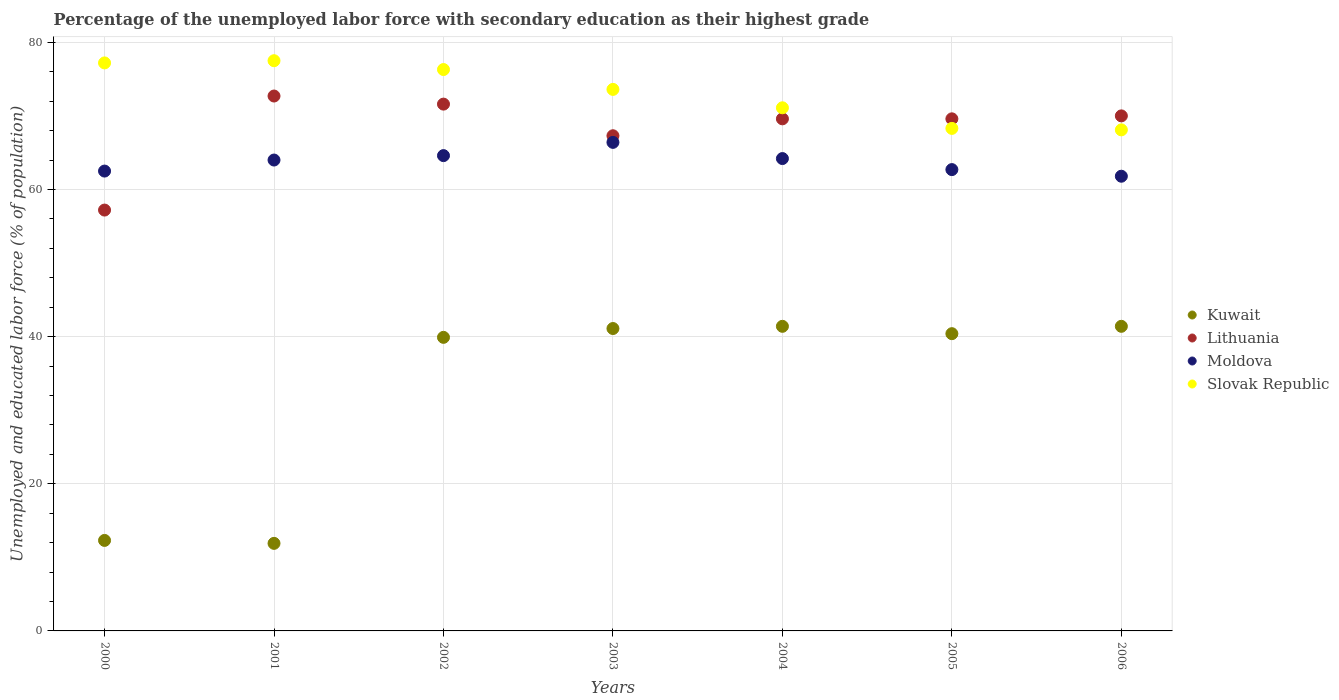Is the number of dotlines equal to the number of legend labels?
Your answer should be compact. Yes. Across all years, what is the maximum percentage of the unemployed labor force with secondary education in Slovak Republic?
Make the answer very short. 77.5. Across all years, what is the minimum percentage of the unemployed labor force with secondary education in Kuwait?
Your answer should be very brief. 11.9. In which year was the percentage of the unemployed labor force with secondary education in Moldova minimum?
Your answer should be compact. 2006. What is the total percentage of the unemployed labor force with secondary education in Lithuania in the graph?
Provide a succinct answer. 478. What is the difference between the percentage of the unemployed labor force with secondary education in Lithuania in 2002 and that in 2006?
Keep it short and to the point. 1.6. What is the difference between the percentage of the unemployed labor force with secondary education in Kuwait in 2003 and the percentage of the unemployed labor force with secondary education in Slovak Republic in 2001?
Offer a very short reply. -36.4. What is the average percentage of the unemployed labor force with secondary education in Lithuania per year?
Your answer should be very brief. 68.29. In the year 2002, what is the difference between the percentage of the unemployed labor force with secondary education in Slovak Republic and percentage of the unemployed labor force with secondary education in Kuwait?
Give a very brief answer. 36.4. What is the ratio of the percentage of the unemployed labor force with secondary education in Lithuania in 2001 to that in 2005?
Make the answer very short. 1.04. Is the difference between the percentage of the unemployed labor force with secondary education in Slovak Republic in 2001 and 2006 greater than the difference between the percentage of the unemployed labor force with secondary education in Kuwait in 2001 and 2006?
Your answer should be compact. Yes. What is the difference between the highest and the second highest percentage of the unemployed labor force with secondary education in Moldova?
Your answer should be compact. 1.8. What is the difference between the highest and the lowest percentage of the unemployed labor force with secondary education in Moldova?
Provide a succinct answer. 4.6. Is the sum of the percentage of the unemployed labor force with secondary education in Lithuania in 2003 and 2004 greater than the maximum percentage of the unemployed labor force with secondary education in Slovak Republic across all years?
Give a very brief answer. Yes. Does the percentage of the unemployed labor force with secondary education in Kuwait monotonically increase over the years?
Offer a very short reply. No. Is the percentage of the unemployed labor force with secondary education in Kuwait strictly less than the percentage of the unemployed labor force with secondary education in Lithuania over the years?
Ensure brevity in your answer.  Yes. How many years are there in the graph?
Provide a short and direct response. 7. Are the values on the major ticks of Y-axis written in scientific E-notation?
Your response must be concise. No. Does the graph contain any zero values?
Your answer should be very brief. No. Does the graph contain grids?
Provide a succinct answer. Yes. How many legend labels are there?
Ensure brevity in your answer.  4. What is the title of the graph?
Offer a terse response. Percentage of the unemployed labor force with secondary education as their highest grade. Does "Kiribati" appear as one of the legend labels in the graph?
Offer a terse response. No. What is the label or title of the Y-axis?
Provide a short and direct response. Unemployed and educated labor force (% of population). What is the Unemployed and educated labor force (% of population) of Kuwait in 2000?
Give a very brief answer. 12.3. What is the Unemployed and educated labor force (% of population) of Lithuania in 2000?
Give a very brief answer. 57.2. What is the Unemployed and educated labor force (% of population) in Moldova in 2000?
Your answer should be very brief. 62.5. What is the Unemployed and educated labor force (% of population) of Slovak Republic in 2000?
Provide a succinct answer. 77.2. What is the Unemployed and educated labor force (% of population) in Kuwait in 2001?
Offer a very short reply. 11.9. What is the Unemployed and educated labor force (% of population) in Lithuania in 2001?
Offer a very short reply. 72.7. What is the Unemployed and educated labor force (% of population) of Moldova in 2001?
Ensure brevity in your answer.  64. What is the Unemployed and educated labor force (% of population) in Slovak Republic in 2001?
Provide a short and direct response. 77.5. What is the Unemployed and educated labor force (% of population) in Kuwait in 2002?
Give a very brief answer. 39.9. What is the Unemployed and educated labor force (% of population) of Lithuania in 2002?
Make the answer very short. 71.6. What is the Unemployed and educated labor force (% of population) in Moldova in 2002?
Your response must be concise. 64.6. What is the Unemployed and educated labor force (% of population) of Slovak Republic in 2002?
Ensure brevity in your answer.  76.3. What is the Unemployed and educated labor force (% of population) of Kuwait in 2003?
Provide a succinct answer. 41.1. What is the Unemployed and educated labor force (% of population) in Lithuania in 2003?
Ensure brevity in your answer.  67.3. What is the Unemployed and educated labor force (% of population) of Moldova in 2003?
Provide a succinct answer. 66.4. What is the Unemployed and educated labor force (% of population) of Slovak Republic in 2003?
Offer a terse response. 73.6. What is the Unemployed and educated labor force (% of population) of Kuwait in 2004?
Provide a succinct answer. 41.4. What is the Unemployed and educated labor force (% of population) of Lithuania in 2004?
Offer a terse response. 69.6. What is the Unemployed and educated labor force (% of population) in Moldova in 2004?
Give a very brief answer. 64.2. What is the Unemployed and educated labor force (% of population) in Slovak Republic in 2004?
Give a very brief answer. 71.1. What is the Unemployed and educated labor force (% of population) in Kuwait in 2005?
Keep it short and to the point. 40.4. What is the Unemployed and educated labor force (% of population) of Lithuania in 2005?
Your response must be concise. 69.6. What is the Unemployed and educated labor force (% of population) in Moldova in 2005?
Provide a succinct answer. 62.7. What is the Unemployed and educated labor force (% of population) in Slovak Republic in 2005?
Your answer should be compact. 68.3. What is the Unemployed and educated labor force (% of population) of Kuwait in 2006?
Offer a terse response. 41.4. What is the Unemployed and educated labor force (% of population) in Lithuania in 2006?
Your answer should be very brief. 70. What is the Unemployed and educated labor force (% of population) in Moldova in 2006?
Offer a very short reply. 61.8. What is the Unemployed and educated labor force (% of population) in Slovak Republic in 2006?
Provide a short and direct response. 68.1. Across all years, what is the maximum Unemployed and educated labor force (% of population) of Kuwait?
Give a very brief answer. 41.4. Across all years, what is the maximum Unemployed and educated labor force (% of population) of Lithuania?
Offer a terse response. 72.7. Across all years, what is the maximum Unemployed and educated labor force (% of population) in Moldova?
Provide a succinct answer. 66.4. Across all years, what is the maximum Unemployed and educated labor force (% of population) in Slovak Republic?
Your response must be concise. 77.5. Across all years, what is the minimum Unemployed and educated labor force (% of population) of Kuwait?
Keep it short and to the point. 11.9. Across all years, what is the minimum Unemployed and educated labor force (% of population) in Lithuania?
Provide a short and direct response. 57.2. Across all years, what is the minimum Unemployed and educated labor force (% of population) in Moldova?
Keep it short and to the point. 61.8. Across all years, what is the minimum Unemployed and educated labor force (% of population) in Slovak Republic?
Your answer should be compact. 68.1. What is the total Unemployed and educated labor force (% of population) of Kuwait in the graph?
Provide a short and direct response. 228.4. What is the total Unemployed and educated labor force (% of population) in Lithuania in the graph?
Make the answer very short. 478. What is the total Unemployed and educated labor force (% of population) in Moldova in the graph?
Keep it short and to the point. 446.2. What is the total Unemployed and educated labor force (% of population) in Slovak Republic in the graph?
Provide a succinct answer. 512.1. What is the difference between the Unemployed and educated labor force (% of population) in Kuwait in 2000 and that in 2001?
Provide a succinct answer. 0.4. What is the difference between the Unemployed and educated labor force (% of population) in Lithuania in 2000 and that in 2001?
Offer a terse response. -15.5. What is the difference between the Unemployed and educated labor force (% of population) in Kuwait in 2000 and that in 2002?
Offer a terse response. -27.6. What is the difference between the Unemployed and educated labor force (% of population) of Lithuania in 2000 and that in 2002?
Keep it short and to the point. -14.4. What is the difference between the Unemployed and educated labor force (% of population) in Kuwait in 2000 and that in 2003?
Ensure brevity in your answer.  -28.8. What is the difference between the Unemployed and educated labor force (% of population) of Lithuania in 2000 and that in 2003?
Provide a short and direct response. -10.1. What is the difference between the Unemployed and educated labor force (% of population) in Moldova in 2000 and that in 2003?
Your answer should be very brief. -3.9. What is the difference between the Unemployed and educated labor force (% of population) in Slovak Republic in 2000 and that in 2003?
Ensure brevity in your answer.  3.6. What is the difference between the Unemployed and educated labor force (% of population) in Kuwait in 2000 and that in 2004?
Your answer should be very brief. -29.1. What is the difference between the Unemployed and educated labor force (% of population) in Moldova in 2000 and that in 2004?
Offer a terse response. -1.7. What is the difference between the Unemployed and educated labor force (% of population) of Slovak Republic in 2000 and that in 2004?
Make the answer very short. 6.1. What is the difference between the Unemployed and educated labor force (% of population) of Kuwait in 2000 and that in 2005?
Your answer should be compact. -28.1. What is the difference between the Unemployed and educated labor force (% of population) of Lithuania in 2000 and that in 2005?
Offer a terse response. -12.4. What is the difference between the Unemployed and educated labor force (% of population) in Moldova in 2000 and that in 2005?
Give a very brief answer. -0.2. What is the difference between the Unemployed and educated labor force (% of population) in Kuwait in 2000 and that in 2006?
Make the answer very short. -29.1. What is the difference between the Unemployed and educated labor force (% of population) in Lithuania in 2000 and that in 2006?
Provide a succinct answer. -12.8. What is the difference between the Unemployed and educated labor force (% of population) of Slovak Republic in 2000 and that in 2006?
Ensure brevity in your answer.  9.1. What is the difference between the Unemployed and educated labor force (% of population) in Moldova in 2001 and that in 2002?
Keep it short and to the point. -0.6. What is the difference between the Unemployed and educated labor force (% of population) of Kuwait in 2001 and that in 2003?
Your answer should be very brief. -29.2. What is the difference between the Unemployed and educated labor force (% of population) in Moldova in 2001 and that in 2003?
Give a very brief answer. -2.4. What is the difference between the Unemployed and educated labor force (% of population) in Slovak Republic in 2001 and that in 2003?
Give a very brief answer. 3.9. What is the difference between the Unemployed and educated labor force (% of population) in Kuwait in 2001 and that in 2004?
Provide a short and direct response. -29.5. What is the difference between the Unemployed and educated labor force (% of population) of Moldova in 2001 and that in 2004?
Provide a succinct answer. -0.2. What is the difference between the Unemployed and educated labor force (% of population) of Kuwait in 2001 and that in 2005?
Your answer should be very brief. -28.5. What is the difference between the Unemployed and educated labor force (% of population) in Lithuania in 2001 and that in 2005?
Offer a terse response. 3.1. What is the difference between the Unemployed and educated labor force (% of population) of Moldova in 2001 and that in 2005?
Your answer should be compact. 1.3. What is the difference between the Unemployed and educated labor force (% of population) in Slovak Republic in 2001 and that in 2005?
Offer a very short reply. 9.2. What is the difference between the Unemployed and educated labor force (% of population) in Kuwait in 2001 and that in 2006?
Offer a terse response. -29.5. What is the difference between the Unemployed and educated labor force (% of population) in Lithuania in 2001 and that in 2006?
Keep it short and to the point. 2.7. What is the difference between the Unemployed and educated labor force (% of population) of Moldova in 2001 and that in 2006?
Your response must be concise. 2.2. What is the difference between the Unemployed and educated labor force (% of population) in Moldova in 2002 and that in 2003?
Your answer should be compact. -1.8. What is the difference between the Unemployed and educated labor force (% of population) of Kuwait in 2002 and that in 2004?
Provide a succinct answer. -1.5. What is the difference between the Unemployed and educated labor force (% of population) of Lithuania in 2002 and that in 2004?
Your answer should be compact. 2. What is the difference between the Unemployed and educated labor force (% of population) of Moldova in 2002 and that in 2004?
Keep it short and to the point. 0.4. What is the difference between the Unemployed and educated labor force (% of population) of Kuwait in 2002 and that in 2005?
Keep it short and to the point. -0.5. What is the difference between the Unemployed and educated labor force (% of population) in Lithuania in 2002 and that in 2005?
Offer a terse response. 2. What is the difference between the Unemployed and educated labor force (% of population) of Moldova in 2002 and that in 2005?
Your answer should be compact. 1.9. What is the difference between the Unemployed and educated labor force (% of population) of Slovak Republic in 2002 and that in 2005?
Make the answer very short. 8. What is the difference between the Unemployed and educated labor force (% of population) in Kuwait in 2002 and that in 2006?
Offer a terse response. -1.5. What is the difference between the Unemployed and educated labor force (% of population) in Slovak Republic in 2002 and that in 2006?
Offer a terse response. 8.2. What is the difference between the Unemployed and educated labor force (% of population) in Lithuania in 2003 and that in 2004?
Your response must be concise. -2.3. What is the difference between the Unemployed and educated labor force (% of population) in Moldova in 2003 and that in 2004?
Offer a very short reply. 2.2. What is the difference between the Unemployed and educated labor force (% of population) in Lithuania in 2003 and that in 2005?
Provide a short and direct response. -2.3. What is the difference between the Unemployed and educated labor force (% of population) in Moldova in 2003 and that in 2005?
Ensure brevity in your answer.  3.7. What is the difference between the Unemployed and educated labor force (% of population) of Lithuania in 2003 and that in 2006?
Your answer should be very brief. -2.7. What is the difference between the Unemployed and educated labor force (% of population) in Moldova in 2003 and that in 2006?
Your answer should be very brief. 4.6. What is the difference between the Unemployed and educated labor force (% of population) in Moldova in 2004 and that in 2005?
Offer a terse response. 1.5. What is the difference between the Unemployed and educated labor force (% of population) in Kuwait in 2004 and that in 2006?
Make the answer very short. 0. What is the difference between the Unemployed and educated labor force (% of population) of Lithuania in 2004 and that in 2006?
Offer a terse response. -0.4. What is the difference between the Unemployed and educated labor force (% of population) in Moldova in 2004 and that in 2006?
Provide a short and direct response. 2.4. What is the difference between the Unemployed and educated labor force (% of population) of Slovak Republic in 2004 and that in 2006?
Offer a terse response. 3. What is the difference between the Unemployed and educated labor force (% of population) of Kuwait in 2005 and that in 2006?
Offer a terse response. -1. What is the difference between the Unemployed and educated labor force (% of population) in Moldova in 2005 and that in 2006?
Your answer should be very brief. 0.9. What is the difference between the Unemployed and educated labor force (% of population) of Slovak Republic in 2005 and that in 2006?
Provide a succinct answer. 0.2. What is the difference between the Unemployed and educated labor force (% of population) in Kuwait in 2000 and the Unemployed and educated labor force (% of population) in Lithuania in 2001?
Keep it short and to the point. -60.4. What is the difference between the Unemployed and educated labor force (% of population) in Kuwait in 2000 and the Unemployed and educated labor force (% of population) in Moldova in 2001?
Provide a short and direct response. -51.7. What is the difference between the Unemployed and educated labor force (% of population) in Kuwait in 2000 and the Unemployed and educated labor force (% of population) in Slovak Republic in 2001?
Offer a terse response. -65.2. What is the difference between the Unemployed and educated labor force (% of population) of Lithuania in 2000 and the Unemployed and educated labor force (% of population) of Slovak Republic in 2001?
Provide a succinct answer. -20.3. What is the difference between the Unemployed and educated labor force (% of population) of Moldova in 2000 and the Unemployed and educated labor force (% of population) of Slovak Republic in 2001?
Your answer should be very brief. -15. What is the difference between the Unemployed and educated labor force (% of population) of Kuwait in 2000 and the Unemployed and educated labor force (% of population) of Lithuania in 2002?
Offer a terse response. -59.3. What is the difference between the Unemployed and educated labor force (% of population) in Kuwait in 2000 and the Unemployed and educated labor force (% of population) in Moldova in 2002?
Keep it short and to the point. -52.3. What is the difference between the Unemployed and educated labor force (% of population) of Kuwait in 2000 and the Unemployed and educated labor force (% of population) of Slovak Republic in 2002?
Make the answer very short. -64. What is the difference between the Unemployed and educated labor force (% of population) of Lithuania in 2000 and the Unemployed and educated labor force (% of population) of Slovak Republic in 2002?
Provide a succinct answer. -19.1. What is the difference between the Unemployed and educated labor force (% of population) in Moldova in 2000 and the Unemployed and educated labor force (% of population) in Slovak Republic in 2002?
Provide a succinct answer. -13.8. What is the difference between the Unemployed and educated labor force (% of population) of Kuwait in 2000 and the Unemployed and educated labor force (% of population) of Lithuania in 2003?
Give a very brief answer. -55. What is the difference between the Unemployed and educated labor force (% of population) in Kuwait in 2000 and the Unemployed and educated labor force (% of population) in Moldova in 2003?
Ensure brevity in your answer.  -54.1. What is the difference between the Unemployed and educated labor force (% of population) of Kuwait in 2000 and the Unemployed and educated labor force (% of population) of Slovak Republic in 2003?
Ensure brevity in your answer.  -61.3. What is the difference between the Unemployed and educated labor force (% of population) in Lithuania in 2000 and the Unemployed and educated labor force (% of population) in Slovak Republic in 2003?
Your answer should be compact. -16.4. What is the difference between the Unemployed and educated labor force (% of population) of Moldova in 2000 and the Unemployed and educated labor force (% of population) of Slovak Republic in 2003?
Keep it short and to the point. -11.1. What is the difference between the Unemployed and educated labor force (% of population) in Kuwait in 2000 and the Unemployed and educated labor force (% of population) in Lithuania in 2004?
Offer a very short reply. -57.3. What is the difference between the Unemployed and educated labor force (% of population) in Kuwait in 2000 and the Unemployed and educated labor force (% of population) in Moldova in 2004?
Make the answer very short. -51.9. What is the difference between the Unemployed and educated labor force (% of population) in Kuwait in 2000 and the Unemployed and educated labor force (% of population) in Slovak Republic in 2004?
Your response must be concise. -58.8. What is the difference between the Unemployed and educated labor force (% of population) of Kuwait in 2000 and the Unemployed and educated labor force (% of population) of Lithuania in 2005?
Provide a succinct answer. -57.3. What is the difference between the Unemployed and educated labor force (% of population) of Kuwait in 2000 and the Unemployed and educated labor force (% of population) of Moldova in 2005?
Offer a terse response. -50.4. What is the difference between the Unemployed and educated labor force (% of population) in Kuwait in 2000 and the Unemployed and educated labor force (% of population) in Slovak Republic in 2005?
Make the answer very short. -56. What is the difference between the Unemployed and educated labor force (% of population) of Lithuania in 2000 and the Unemployed and educated labor force (% of population) of Moldova in 2005?
Offer a very short reply. -5.5. What is the difference between the Unemployed and educated labor force (% of population) in Lithuania in 2000 and the Unemployed and educated labor force (% of population) in Slovak Republic in 2005?
Offer a very short reply. -11.1. What is the difference between the Unemployed and educated labor force (% of population) of Kuwait in 2000 and the Unemployed and educated labor force (% of population) of Lithuania in 2006?
Give a very brief answer. -57.7. What is the difference between the Unemployed and educated labor force (% of population) of Kuwait in 2000 and the Unemployed and educated labor force (% of population) of Moldova in 2006?
Your answer should be compact. -49.5. What is the difference between the Unemployed and educated labor force (% of population) of Kuwait in 2000 and the Unemployed and educated labor force (% of population) of Slovak Republic in 2006?
Provide a succinct answer. -55.8. What is the difference between the Unemployed and educated labor force (% of population) in Lithuania in 2000 and the Unemployed and educated labor force (% of population) in Moldova in 2006?
Your answer should be compact. -4.6. What is the difference between the Unemployed and educated labor force (% of population) in Lithuania in 2000 and the Unemployed and educated labor force (% of population) in Slovak Republic in 2006?
Provide a succinct answer. -10.9. What is the difference between the Unemployed and educated labor force (% of population) in Kuwait in 2001 and the Unemployed and educated labor force (% of population) in Lithuania in 2002?
Your answer should be compact. -59.7. What is the difference between the Unemployed and educated labor force (% of population) of Kuwait in 2001 and the Unemployed and educated labor force (% of population) of Moldova in 2002?
Make the answer very short. -52.7. What is the difference between the Unemployed and educated labor force (% of population) of Kuwait in 2001 and the Unemployed and educated labor force (% of population) of Slovak Republic in 2002?
Your answer should be compact. -64.4. What is the difference between the Unemployed and educated labor force (% of population) of Kuwait in 2001 and the Unemployed and educated labor force (% of population) of Lithuania in 2003?
Provide a short and direct response. -55.4. What is the difference between the Unemployed and educated labor force (% of population) in Kuwait in 2001 and the Unemployed and educated labor force (% of population) in Moldova in 2003?
Your answer should be very brief. -54.5. What is the difference between the Unemployed and educated labor force (% of population) in Kuwait in 2001 and the Unemployed and educated labor force (% of population) in Slovak Republic in 2003?
Provide a short and direct response. -61.7. What is the difference between the Unemployed and educated labor force (% of population) in Kuwait in 2001 and the Unemployed and educated labor force (% of population) in Lithuania in 2004?
Provide a succinct answer. -57.7. What is the difference between the Unemployed and educated labor force (% of population) of Kuwait in 2001 and the Unemployed and educated labor force (% of population) of Moldova in 2004?
Your answer should be very brief. -52.3. What is the difference between the Unemployed and educated labor force (% of population) of Kuwait in 2001 and the Unemployed and educated labor force (% of population) of Slovak Republic in 2004?
Provide a succinct answer. -59.2. What is the difference between the Unemployed and educated labor force (% of population) in Lithuania in 2001 and the Unemployed and educated labor force (% of population) in Slovak Republic in 2004?
Keep it short and to the point. 1.6. What is the difference between the Unemployed and educated labor force (% of population) of Kuwait in 2001 and the Unemployed and educated labor force (% of population) of Lithuania in 2005?
Ensure brevity in your answer.  -57.7. What is the difference between the Unemployed and educated labor force (% of population) of Kuwait in 2001 and the Unemployed and educated labor force (% of population) of Moldova in 2005?
Provide a succinct answer. -50.8. What is the difference between the Unemployed and educated labor force (% of population) of Kuwait in 2001 and the Unemployed and educated labor force (% of population) of Slovak Republic in 2005?
Offer a terse response. -56.4. What is the difference between the Unemployed and educated labor force (% of population) in Lithuania in 2001 and the Unemployed and educated labor force (% of population) in Moldova in 2005?
Keep it short and to the point. 10. What is the difference between the Unemployed and educated labor force (% of population) of Lithuania in 2001 and the Unemployed and educated labor force (% of population) of Slovak Republic in 2005?
Your answer should be compact. 4.4. What is the difference between the Unemployed and educated labor force (% of population) of Moldova in 2001 and the Unemployed and educated labor force (% of population) of Slovak Republic in 2005?
Your answer should be compact. -4.3. What is the difference between the Unemployed and educated labor force (% of population) in Kuwait in 2001 and the Unemployed and educated labor force (% of population) in Lithuania in 2006?
Offer a terse response. -58.1. What is the difference between the Unemployed and educated labor force (% of population) in Kuwait in 2001 and the Unemployed and educated labor force (% of population) in Moldova in 2006?
Provide a short and direct response. -49.9. What is the difference between the Unemployed and educated labor force (% of population) in Kuwait in 2001 and the Unemployed and educated labor force (% of population) in Slovak Republic in 2006?
Keep it short and to the point. -56.2. What is the difference between the Unemployed and educated labor force (% of population) in Lithuania in 2001 and the Unemployed and educated labor force (% of population) in Moldova in 2006?
Ensure brevity in your answer.  10.9. What is the difference between the Unemployed and educated labor force (% of population) in Lithuania in 2001 and the Unemployed and educated labor force (% of population) in Slovak Republic in 2006?
Keep it short and to the point. 4.6. What is the difference between the Unemployed and educated labor force (% of population) of Moldova in 2001 and the Unemployed and educated labor force (% of population) of Slovak Republic in 2006?
Provide a short and direct response. -4.1. What is the difference between the Unemployed and educated labor force (% of population) of Kuwait in 2002 and the Unemployed and educated labor force (% of population) of Lithuania in 2003?
Provide a short and direct response. -27.4. What is the difference between the Unemployed and educated labor force (% of population) of Kuwait in 2002 and the Unemployed and educated labor force (% of population) of Moldova in 2003?
Give a very brief answer. -26.5. What is the difference between the Unemployed and educated labor force (% of population) of Kuwait in 2002 and the Unemployed and educated labor force (% of population) of Slovak Republic in 2003?
Provide a succinct answer. -33.7. What is the difference between the Unemployed and educated labor force (% of population) in Lithuania in 2002 and the Unemployed and educated labor force (% of population) in Slovak Republic in 2003?
Provide a short and direct response. -2. What is the difference between the Unemployed and educated labor force (% of population) in Moldova in 2002 and the Unemployed and educated labor force (% of population) in Slovak Republic in 2003?
Your answer should be compact. -9. What is the difference between the Unemployed and educated labor force (% of population) of Kuwait in 2002 and the Unemployed and educated labor force (% of population) of Lithuania in 2004?
Your answer should be very brief. -29.7. What is the difference between the Unemployed and educated labor force (% of population) of Kuwait in 2002 and the Unemployed and educated labor force (% of population) of Moldova in 2004?
Your answer should be very brief. -24.3. What is the difference between the Unemployed and educated labor force (% of population) of Kuwait in 2002 and the Unemployed and educated labor force (% of population) of Slovak Republic in 2004?
Offer a very short reply. -31.2. What is the difference between the Unemployed and educated labor force (% of population) of Lithuania in 2002 and the Unemployed and educated labor force (% of population) of Slovak Republic in 2004?
Your answer should be very brief. 0.5. What is the difference between the Unemployed and educated labor force (% of population) in Moldova in 2002 and the Unemployed and educated labor force (% of population) in Slovak Republic in 2004?
Offer a terse response. -6.5. What is the difference between the Unemployed and educated labor force (% of population) in Kuwait in 2002 and the Unemployed and educated labor force (% of population) in Lithuania in 2005?
Your answer should be compact. -29.7. What is the difference between the Unemployed and educated labor force (% of population) in Kuwait in 2002 and the Unemployed and educated labor force (% of population) in Moldova in 2005?
Your answer should be compact. -22.8. What is the difference between the Unemployed and educated labor force (% of population) of Kuwait in 2002 and the Unemployed and educated labor force (% of population) of Slovak Republic in 2005?
Offer a very short reply. -28.4. What is the difference between the Unemployed and educated labor force (% of population) of Moldova in 2002 and the Unemployed and educated labor force (% of population) of Slovak Republic in 2005?
Provide a succinct answer. -3.7. What is the difference between the Unemployed and educated labor force (% of population) of Kuwait in 2002 and the Unemployed and educated labor force (% of population) of Lithuania in 2006?
Your answer should be very brief. -30.1. What is the difference between the Unemployed and educated labor force (% of population) in Kuwait in 2002 and the Unemployed and educated labor force (% of population) in Moldova in 2006?
Make the answer very short. -21.9. What is the difference between the Unemployed and educated labor force (% of population) in Kuwait in 2002 and the Unemployed and educated labor force (% of population) in Slovak Republic in 2006?
Keep it short and to the point. -28.2. What is the difference between the Unemployed and educated labor force (% of population) in Lithuania in 2002 and the Unemployed and educated labor force (% of population) in Moldova in 2006?
Give a very brief answer. 9.8. What is the difference between the Unemployed and educated labor force (% of population) in Lithuania in 2002 and the Unemployed and educated labor force (% of population) in Slovak Republic in 2006?
Keep it short and to the point. 3.5. What is the difference between the Unemployed and educated labor force (% of population) of Moldova in 2002 and the Unemployed and educated labor force (% of population) of Slovak Republic in 2006?
Provide a succinct answer. -3.5. What is the difference between the Unemployed and educated labor force (% of population) in Kuwait in 2003 and the Unemployed and educated labor force (% of population) in Lithuania in 2004?
Give a very brief answer. -28.5. What is the difference between the Unemployed and educated labor force (% of population) of Kuwait in 2003 and the Unemployed and educated labor force (% of population) of Moldova in 2004?
Your response must be concise. -23.1. What is the difference between the Unemployed and educated labor force (% of population) in Kuwait in 2003 and the Unemployed and educated labor force (% of population) in Slovak Republic in 2004?
Offer a very short reply. -30. What is the difference between the Unemployed and educated labor force (% of population) of Lithuania in 2003 and the Unemployed and educated labor force (% of population) of Moldova in 2004?
Your answer should be compact. 3.1. What is the difference between the Unemployed and educated labor force (% of population) in Lithuania in 2003 and the Unemployed and educated labor force (% of population) in Slovak Republic in 2004?
Offer a very short reply. -3.8. What is the difference between the Unemployed and educated labor force (% of population) of Moldova in 2003 and the Unemployed and educated labor force (% of population) of Slovak Republic in 2004?
Provide a short and direct response. -4.7. What is the difference between the Unemployed and educated labor force (% of population) of Kuwait in 2003 and the Unemployed and educated labor force (% of population) of Lithuania in 2005?
Offer a very short reply. -28.5. What is the difference between the Unemployed and educated labor force (% of population) in Kuwait in 2003 and the Unemployed and educated labor force (% of population) in Moldova in 2005?
Give a very brief answer. -21.6. What is the difference between the Unemployed and educated labor force (% of population) in Kuwait in 2003 and the Unemployed and educated labor force (% of population) in Slovak Republic in 2005?
Make the answer very short. -27.2. What is the difference between the Unemployed and educated labor force (% of population) of Moldova in 2003 and the Unemployed and educated labor force (% of population) of Slovak Republic in 2005?
Keep it short and to the point. -1.9. What is the difference between the Unemployed and educated labor force (% of population) of Kuwait in 2003 and the Unemployed and educated labor force (% of population) of Lithuania in 2006?
Give a very brief answer. -28.9. What is the difference between the Unemployed and educated labor force (% of population) of Kuwait in 2003 and the Unemployed and educated labor force (% of population) of Moldova in 2006?
Offer a very short reply. -20.7. What is the difference between the Unemployed and educated labor force (% of population) of Lithuania in 2003 and the Unemployed and educated labor force (% of population) of Moldova in 2006?
Make the answer very short. 5.5. What is the difference between the Unemployed and educated labor force (% of population) of Lithuania in 2003 and the Unemployed and educated labor force (% of population) of Slovak Republic in 2006?
Give a very brief answer. -0.8. What is the difference between the Unemployed and educated labor force (% of population) in Moldova in 2003 and the Unemployed and educated labor force (% of population) in Slovak Republic in 2006?
Provide a short and direct response. -1.7. What is the difference between the Unemployed and educated labor force (% of population) of Kuwait in 2004 and the Unemployed and educated labor force (% of population) of Lithuania in 2005?
Give a very brief answer. -28.2. What is the difference between the Unemployed and educated labor force (% of population) in Kuwait in 2004 and the Unemployed and educated labor force (% of population) in Moldova in 2005?
Your response must be concise. -21.3. What is the difference between the Unemployed and educated labor force (% of population) in Kuwait in 2004 and the Unemployed and educated labor force (% of population) in Slovak Republic in 2005?
Ensure brevity in your answer.  -26.9. What is the difference between the Unemployed and educated labor force (% of population) in Lithuania in 2004 and the Unemployed and educated labor force (% of population) in Slovak Republic in 2005?
Provide a short and direct response. 1.3. What is the difference between the Unemployed and educated labor force (% of population) of Moldova in 2004 and the Unemployed and educated labor force (% of population) of Slovak Republic in 2005?
Ensure brevity in your answer.  -4.1. What is the difference between the Unemployed and educated labor force (% of population) in Kuwait in 2004 and the Unemployed and educated labor force (% of population) in Lithuania in 2006?
Offer a terse response. -28.6. What is the difference between the Unemployed and educated labor force (% of population) of Kuwait in 2004 and the Unemployed and educated labor force (% of population) of Moldova in 2006?
Your answer should be compact. -20.4. What is the difference between the Unemployed and educated labor force (% of population) in Kuwait in 2004 and the Unemployed and educated labor force (% of population) in Slovak Republic in 2006?
Your response must be concise. -26.7. What is the difference between the Unemployed and educated labor force (% of population) of Lithuania in 2004 and the Unemployed and educated labor force (% of population) of Moldova in 2006?
Your answer should be very brief. 7.8. What is the difference between the Unemployed and educated labor force (% of population) of Lithuania in 2004 and the Unemployed and educated labor force (% of population) of Slovak Republic in 2006?
Provide a short and direct response. 1.5. What is the difference between the Unemployed and educated labor force (% of population) in Moldova in 2004 and the Unemployed and educated labor force (% of population) in Slovak Republic in 2006?
Keep it short and to the point. -3.9. What is the difference between the Unemployed and educated labor force (% of population) of Kuwait in 2005 and the Unemployed and educated labor force (% of population) of Lithuania in 2006?
Your answer should be compact. -29.6. What is the difference between the Unemployed and educated labor force (% of population) in Kuwait in 2005 and the Unemployed and educated labor force (% of population) in Moldova in 2006?
Keep it short and to the point. -21.4. What is the difference between the Unemployed and educated labor force (% of population) in Kuwait in 2005 and the Unemployed and educated labor force (% of population) in Slovak Republic in 2006?
Your response must be concise. -27.7. What is the difference between the Unemployed and educated labor force (% of population) in Lithuania in 2005 and the Unemployed and educated labor force (% of population) in Slovak Republic in 2006?
Ensure brevity in your answer.  1.5. What is the difference between the Unemployed and educated labor force (% of population) of Moldova in 2005 and the Unemployed and educated labor force (% of population) of Slovak Republic in 2006?
Give a very brief answer. -5.4. What is the average Unemployed and educated labor force (% of population) of Kuwait per year?
Provide a succinct answer. 32.63. What is the average Unemployed and educated labor force (% of population) in Lithuania per year?
Ensure brevity in your answer.  68.29. What is the average Unemployed and educated labor force (% of population) of Moldova per year?
Provide a short and direct response. 63.74. What is the average Unemployed and educated labor force (% of population) of Slovak Republic per year?
Your answer should be very brief. 73.16. In the year 2000, what is the difference between the Unemployed and educated labor force (% of population) in Kuwait and Unemployed and educated labor force (% of population) in Lithuania?
Offer a terse response. -44.9. In the year 2000, what is the difference between the Unemployed and educated labor force (% of population) of Kuwait and Unemployed and educated labor force (% of population) of Moldova?
Offer a terse response. -50.2. In the year 2000, what is the difference between the Unemployed and educated labor force (% of population) in Kuwait and Unemployed and educated labor force (% of population) in Slovak Republic?
Provide a short and direct response. -64.9. In the year 2000, what is the difference between the Unemployed and educated labor force (% of population) of Moldova and Unemployed and educated labor force (% of population) of Slovak Republic?
Provide a succinct answer. -14.7. In the year 2001, what is the difference between the Unemployed and educated labor force (% of population) in Kuwait and Unemployed and educated labor force (% of population) in Lithuania?
Provide a succinct answer. -60.8. In the year 2001, what is the difference between the Unemployed and educated labor force (% of population) of Kuwait and Unemployed and educated labor force (% of population) of Moldova?
Make the answer very short. -52.1. In the year 2001, what is the difference between the Unemployed and educated labor force (% of population) in Kuwait and Unemployed and educated labor force (% of population) in Slovak Republic?
Your answer should be compact. -65.6. In the year 2001, what is the difference between the Unemployed and educated labor force (% of population) of Lithuania and Unemployed and educated labor force (% of population) of Slovak Republic?
Keep it short and to the point. -4.8. In the year 2001, what is the difference between the Unemployed and educated labor force (% of population) of Moldova and Unemployed and educated labor force (% of population) of Slovak Republic?
Give a very brief answer. -13.5. In the year 2002, what is the difference between the Unemployed and educated labor force (% of population) of Kuwait and Unemployed and educated labor force (% of population) of Lithuania?
Your answer should be compact. -31.7. In the year 2002, what is the difference between the Unemployed and educated labor force (% of population) of Kuwait and Unemployed and educated labor force (% of population) of Moldova?
Make the answer very short. -24.7. In the year 2002, what is the difference between the Unemployed and educated labor force (% of population) of Kuwait and Unemployed and educated labor force (% of population) of Slovak Republic?
Provide a succinct answer. -36.4. In the year 2002, what is the difference between the Unemployed and educated labor force (% of population) of Lithuania and Unemployed and educated labor force (% of population) of Moldova?
Provide a succinct answer. 7. In the year 2002, what is the difference between the Unemployed and educated labor force (% of population) of Moldova and Unemployed and educated labor force (% of population) of Slovak Republic?
Offer a very short reply. -11.7. In the year 2003, what is the difference between the Unemployed and educated labor force (% of population) in Kuwait and Unemployed and educated labor force (% of population) in Lithuania?
Your response must be concise. -26.2. In the year 2003, what is the difference between the Unemployed and educated labor force (% of population) in Kuwait and Unemployed and educated labor force (% of population) in Moldova?
Offer a very short reply. -25.3. In the year 2003, what is the difference between the Unemployed and educated labor force (% of population) in Kuwait and Unemployed and educated labor force (% of population) in Slovak Republic?
Give a very brief answer. -32.5. In the year 2003, what is the difference between the Unemployed and educated labor force (% of population) in Moldova and Unemployed and educated labor force (% of population) in Slovak Republic?
Give a very brief answer. -7.2. In the year 2004, what is the difference between the Unemployed and educated labor force (% of population) in Kuwait and Unemployed and educated labor force (% of population) in Lithuania?
Give a very brief answer. -28.2. In the year 2004, what is the difference between the Unemployed and educated labor force (% of population) of Kuwait and Unemployed and educated labor force (% of population) of Moldova?
Provide a succinct answer. -22.8. In the year 2004, what is the difference between the Unemployed and educated labor force (% of population) in Kuwait and Unemployed and educated labor force (% of population) in Slovak Republic?
Ensure brevity in your answer.  -29.7. In the year 2004, what is the difference between the Unemployed and educated labor force (% of population) of Lithuania and Unemployed and educated labor force (% of population) of Moldova?
Your answer should be compact. 5.4. In the year 2004, what is the difference between the Unemployed and educated labor force (% of population) in Lithuania and Unemployed and educated labor force (% of population) in Slovak Republic?
Provide a succinct answer. -1.5. In the year 2004, what is the difference between the Unemployed and educated labor force (% of population) of Moldova and Unemployed and educated labor force (% of population) of Slovak Republic?
Provide a succinct answer. -6.9. In the year 2005, what is the difference between the Unemployed and educated labor force (% of population) of Kuwait and Unemployed and educated labor force (% of population) of Lithuania?
Ensure brevity in your answer.  -29.2. In the year 2005, what is the difference between the Unemployed and educated labor force (% of population) in Kuwait and Unemployed and educated labor force (% of population) in Moldova?
Offer a terse response. -22.3. In the year 2005, what is the difference between the Unemployed and educated labor force (% of population) in Kuwait and Unemployed and educated labor force (% of population) in Slovak Republic?
Provide a short and direct response. -27.9. In the year 2005, what is the difference between the Unemployed and educated labor force (% of population) in Lithuania and Unemployed and educated labor force (% of population) in Moldova?
Offer a very short reply. 6.9. In the year 2005, what is the difference between the Unemployed and educated labor force (% of population) in Lithuania and Unemployed and educated labor force (% of population) in Slovak Republic?
Give a very brief answer. 1.3. In the year 2006, what is the difference between the Unemployed and educated labor force (% of population) in Kuwait and Unemployed and educated labor force (% of population) in Lithuania?
Provide a succinct answer. -28.6. In the year 2006, what is the difference between the Unemployed and educated labor force (% of population) of Kuwait and Unemployed and educated labor force (% of population) of Moldova?
Your answer should be compact. -20.4. In the year 2006, what is the difference between the Unemployed and educated labor force (% of population) of Kuwait and Unemployed and educated labor force (% of population) of Slovak Republic?
Offer a terse response. -26.7. In the year 2006, what is the difference between the Unemployed and educated labor force (% of population) of Lithuania and Unemployed and educated labor force (% of population) of Moldova?
Offer a very short reply. 8.2. What is the ratio of the Unemployed and educated labor force (% of population) of Kuwait in 2000 to that in 2001?
Provide a short and direct response. 1.03. What is the ratio of the Unemployed and educated labor force (% of population) in Lithuania in 2000 to that in 2001?
Your response must be concise. 0.79. What is the ratio of the Unemployed and educated labor force (% of population) in Moldova in 2000 to that in 2001?
Provide a short and direct response. 0.98. What is the ratio of the Unemployed and educated labor force (% of population) in Kuwait in 2000 to that in 2002?
Make the answer very short. 0.31. What is the ratio of the Unemployed and educated labor force (% of population) of Lithuania in 2000 to that in 2002?
Offer a very short reply. 0.8. What is the ratio of the Unemployed and educated labor force (% of population) in Moldova in 2000 to that in 2002?
Make the answer very short. 0.97. What is the ratio of the Unemployed and educated labor force (% of population) of Slovak Republic in 2000 to that in 2002?
Offer a very short reply. 1.01. What is the ratio of the Unemployed and educated labor force (% of population) of Kuwait in 2000 to that in 2003?
Ensure brevity in your answer.  0.3. What is the ratio of the Unemployed and educated labor force (% of population) of Lithuania in 2000 to that in 2003?
Provide a succinct answer. 0.85. What is the ratio of the Unemployed and educated labor force (% of population) in Moldova in 2000 to that in 2003?
Your answer should be very brief. 0.94. What is the ratio of the Unemployed and educated labor force (% of population) of Slovak Republic in 2000 to that in 2003?
Keep it short and to the point. 1.05. What is the ratio of the Unemployed and educated labor force (% of population) of Kuwait in 2000 to that in 2004?
Make the answer very short. 0.3. What is the ratio of the Unemployed and educated labor force (% of population) of Lithuania in 2000 to that in 2004?
Offer a very short reply. 0.82. What is the ratio of the Unemployed and educated labor force (% of population) in Moldova in 2000 to that in 2004?
Ensure brevity in your answer.  0.97. What is the ratio of the Unemployed and educated labor force (% of population) of Slovak Republic in 2000 to that in 2004?
Provide a short and direct response. 1.09. What is the ratio of the Unemployed and educated labor force (% of population) of Kuwait in 2000 to that in 2005?
Your response must be concise. 0.3. What is the ratio of the Unemployed and educated labor force (% of population) of Lithuania in 2000 to that in 2005?
Offer a terse response. 0.82. What is the ratio of the Unemployed and educated labor force (% of population) in Slovak Republic in 2000 to that in 2005?
Make the answer very short. 1.13. What is the ratio of the Unemployed and educated labor force (% of population) in Kuwait in 2000 to that in 2006?
Offer a terse response. 0.3. What is the ratio of the Unemployed and educated labor force (% of population) in Lithuania in 2000 to that in 2006?
Ensure brevity in your answer.  0.82. What is the ratio of the Unemployed and educated labor force (% of population) in Moldova in 2000 to that in 2006?
Offer a terse response. 1.01. What is the ratio of the Unemployed and educated labor force (% of population) in Slovak Republic in 2000 to that in 2006?
Offer a very short reply. 1.13. What is the ratio of the Unemployed and educated labor force (% of population) in Kuwait in 2001 to that in 2002?
Your answer should be compact. 0.3. What is the ratio of the Unemployed and educated labor force (% of population) of Lithuania in 2001 to that in 2002?
Your answer should be very brief. 1.02. What is the ratio of the Unemployed and educated labor force (% of population) in Moldova in 2001 to that in 2002?
Your answer should be very brief. 0.99. What is the ratio of the Unemployed and educated labor force (% of population) of Slovak Republic in 2001 to that in 2002?
Ensure brevity in your answer.  1.02. What is the ratio of the Unemployed and educated labor force (% of population) of Kuwait in 2001 to that in 2003?
Offer a terse response. 0.29. What is the ratio of the Unemployed and educated labor force (% of population) in Lithuania in 2001 to that in 2003?
Ensure brevity in your answer.  1.08. What is the ratio of the Unemployed and educated labor force (% of population) of Moldova in 2001 to that in 2003?
Keep it short and to the point. 0.96. What is the ratio of the Unemployed and educated labor force (% of population) of Slovak Republic in 2001 to that in 2003?
Your answer should be very brief. 1.05. What is the ratio of the Unemployed and educated labor force (% of population) in Kuwait in 2001 to that in 2004?
Offer a very short reply. 0.29. What is the ratio of the Unemployed and educated labor force (% of population) of Lithuania in 2001 to that in 2004?
Your response must be concise. 1.04. What is the ratio of the Unemployed and educated labor force (% of population) of Slovak Republic in 2001 to that in 2004?
Your answer should be very brief. 1.09. What is the ratio of the Unemployed and educated labor force (% of population) in Kuwait in 2001 to that in 2005?
Provide a succinct answer. 0.29. What is the ratio of the Unemployed and educated labor force (% of population) of Lithuania in 2001 to that in 2005?
Your answer should be very brief. 1.04. What is the ratio of the Unemployed and educated labor force (% of population) in Moldova in 2001 to that in 2005?
Your answer should be very brief. 1.02. What is the ratio of the Unemployed and educated labor force (% of population) in Slovak Republic in 2001 to that in 2005?
Your response must be concise. 1.13. What is the ratio of the Unemployed and educated labor force (% of population) of Kuwait in 2001 to that in 2006?
Your answer should be compact. 0.29. What is the ratio of the Unemployed and educated labor force (% of population) of Lithuania in 2001 to that in 2006?
Make the answer very short. 1.04. What is the ratio of the Unemployed and educated labor force (% of population) of Moldova in 2001 to that in 2006?
Your response must be concise. 1.04. What is the ratio of the Unemployed and educated labor force (% of population) in Slovak Republic in 2001 to that in 2006?
Offer a terse response. 1.14. What is the ratio of the Unemployed and educated labor force (% of population) of Kuwait in 2002 to that in 2003?
Ensure brevity in your answer.  0.97. What is the ratio of the Unemployed and educated labor force (% of population) of Lithuania in 2002 to that in 2003?
Keep it short and to the point. 1.06. What is the ratio of the Unemployed and educated labor force (% of population) of Moldova in 2002 to that in 2003?
Your answer should be compact. 0.97. What is the ratio of the Unemployed and educated labor force (% of population) in Slovak Republic in 2002 to that in 2003?
Offer a very short reply. 1.04. What is the ratio of the Unemployed and educated labor force (% of population) of Kuwait in 2002 to that in 2004?
Your answer should be very brief. 0.96. What is the ratio of the Unemployed and educated labor force (% of population) of Lithuania in 2002 to that in 2004?
Your answer should be compact. 1.03. What is the ratio of the Unemployed and educated labor force (% of population) of Moldova in 2002 to that in 2004?
Provide a succinct answer. 1.01. What is the ratio of the Unemployed and educated labor force (% of population) of Slovak Republic in 2002 to that in 2004?
Make the answer very short. 1.07. What is the ratio of the Unemployed and educated labor force (% of population) of Kuwait in 2002 to that in 2005?
Your answer should be compact. 0.99. What is the ratio of the Unemployed and educated labor force (% of population) of Lithuania in 2002 to that in 2005?
Give a very brief answer. 1.03. What is the ratio of the Unemployed and educated labor force (% of population) in Moldova in 2002 to that in 2005?
Provide a succinct answer. 1.03. What is the ratio of the Unemployed and educated labor force (% of population) in Slovak Republic in 2002 to that in 2005?
Give a very brief answer. 1.12. What is the ratio of the Unemployed and educated labor force (% of population) in Kuwait in 2002 to that in 2006?
Give a very brief answer. 0.96. What is the ratio of the Unemployed and educated labor force (% of population) in Lithuania in 2002 to that in 2006?
Give a very brief answer. 1.02. What is the ratio of the Unemployed and educated labor force (% of population) in Moldova in 2002 to that in 2006?
Your answer should be compact. 1.05. What is the ratio of the Unemployed and educated labor force (% of population) in Slovak Republic in 2002 to that in 2006?
Provide a succinct answer. 1.12. What is the ratio of the Unemployed and educated labor force (% of population) of Moldova in 2003 to that in 2004?
Your response must be concise. 1.03. What is the ratio of the Unemployed and educated labor force (% of population) in Slovak Republic in 2003 to that in 2004?
Offer a very short reply. 1.04. What is the ratio of the Unemployed and educated labor force (% of population) of Kuwait in 2003 to that in 2005?
Offer a very short reply. 1.02. What is the ratio of the Unemployed and educated labor force (% of population) in Lithuania in 2003 to that in 2005?
Offer a terse response. 0.97. What is the ratio of the Unemployed and educated labor force (% of population) in Moldova in 2003 to that in 2005?
Provide a short and direct response. 1.06. What is the ratio of the Unemployed and educated labor force (% of population) in Slovak Republic in 2003 to that in 2005?
Give a very brief answer. 1.08. What is the ratio of the Unemployed and educated labor force (% of population) of Lithuania in 2003 to that in 2006?
Offer a very short reply. 0.96. What is the ratio of the Unemployed and educated labor force (% of population) of Moldova in 2003 to that in 2006?
Offer a very short reply. 1.07. What is the ratio of the Unemployed and educated labor force (% of population) in Slovak Republic in 2003 to that in 2006?
Provide a succinct answer. 1.08. What is the ratio of the Unemployed and educated labor force (% of population) of Kuwait in 2004 to that in 2005?
Provide a short and direct response. 1.02. What is the ratio of the Unemployed and educated labor force (% of population) in Lithuania in 2004 to that in 2005?
Provide a succinct answer. 1. What is the ratio of the Unemployed and educated labor force (% of population) in Moldova in 2004 to that in 2005?
Offer a terse response. 1.02. What is the ratio of the Unemployed and educated labor force (% of population) of Slovak Republic in 2004 to that in 2005?
Make the answer very short. 1.04. What is the ratio of the Unemployed and educated labor force (% of population) in Kuwait in 2004 to that in 2006?
Give a very brief answer. 1. What is the ratio of the Unemployed and educated labor force (% of population) in Lithuania in 2004 to that in 2006?
Provide a succinct answer. 0.99. What is the ratio of the Unemployed and educated labor force (% of population) in Moldova in 2004 to that in 2006?
Your answer should be compact. 1.04. What is the ratio of the Unemployed and educated labor force (% of population) in Slovak Republic in 2004 to that in 2006?
Offer a terse response. 1.04. What is the ratio of the Unemployed and educated labor force (% of population) of Kuwait in 2005 to that in 2006?
Ensure brevity in your answer.  0.98. What is the ratio of the Unemployed and educated labor force (% of population) in Lithuania in 2005 to that in 2006?
Offer a very short reply. 0.99. What is the ratio of the Unemployed and educated labor force (% of population) in Moldova in 2005 to that in 2006?
Make the answer very short. 1.01. What is the ratio of the Unemployed and educated labor force (% of population) of Slovak Republic in 2005 to that in 2006?
Offer a very short reply. 1. What is the difference between the highest and the second highest Unemployed and educated labor force (% of population) of Kuwait?
Provide a short and direct response. 0. What is the difference between the highest and the second highest Unemployed and educated labor force (% of population) in Moldova?
Provide a succinct answer. 1.8. What is the difference between the highest and the second highest Unemployed and educated labor force (% of population) of Slovak Republic?
Keep it short and to the point. 0.3. What is the difference between the highest and the lowest Unemployed and educated labor force (% of population) in Kuwait?
Your answer should be compact. 29.5. What is the difference between the highest and the lowest Unemployed and educated labor force (% of population) in Slovak Republic?
Provide a short and direct response. 9.4. 